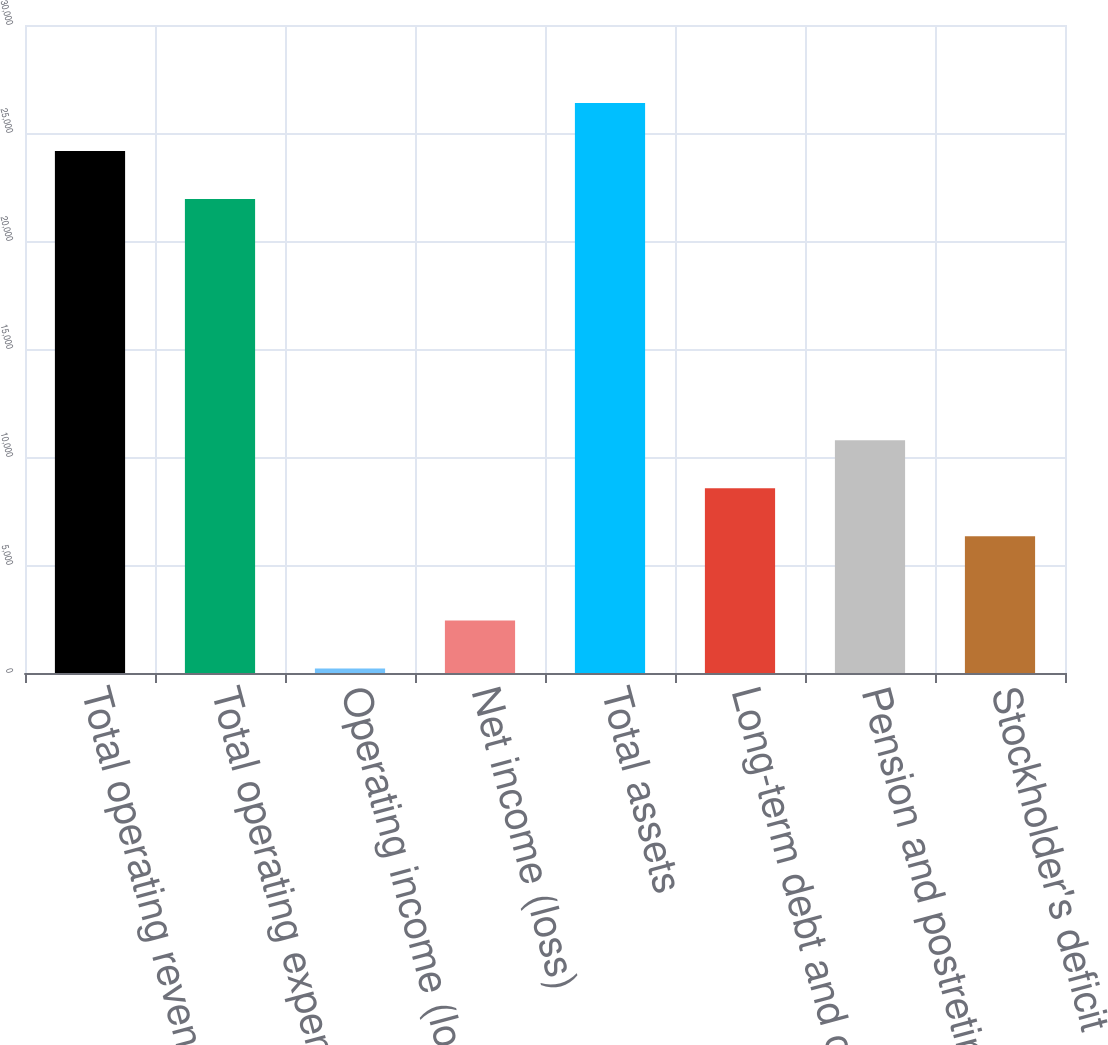<chart> <loc_0><loc_0><loc_500><loc_500><bar_chart><fcel>Total operating revenues<fcel>Total operating expenses<fcel>Operating income (loss)<fcel>Net income (loss)<fcel>Total assets<fcel>Long-term debt and capital<fcel>Pension and postretirement<fcel>Stockholder's deficit<nl><fcel>24166.6<fcel>21945<fcel>206<fcel>2427.6<fcel>26388.2<fcel>8557.6<fcel>10779.2<fcel>6336<nl></chart> 